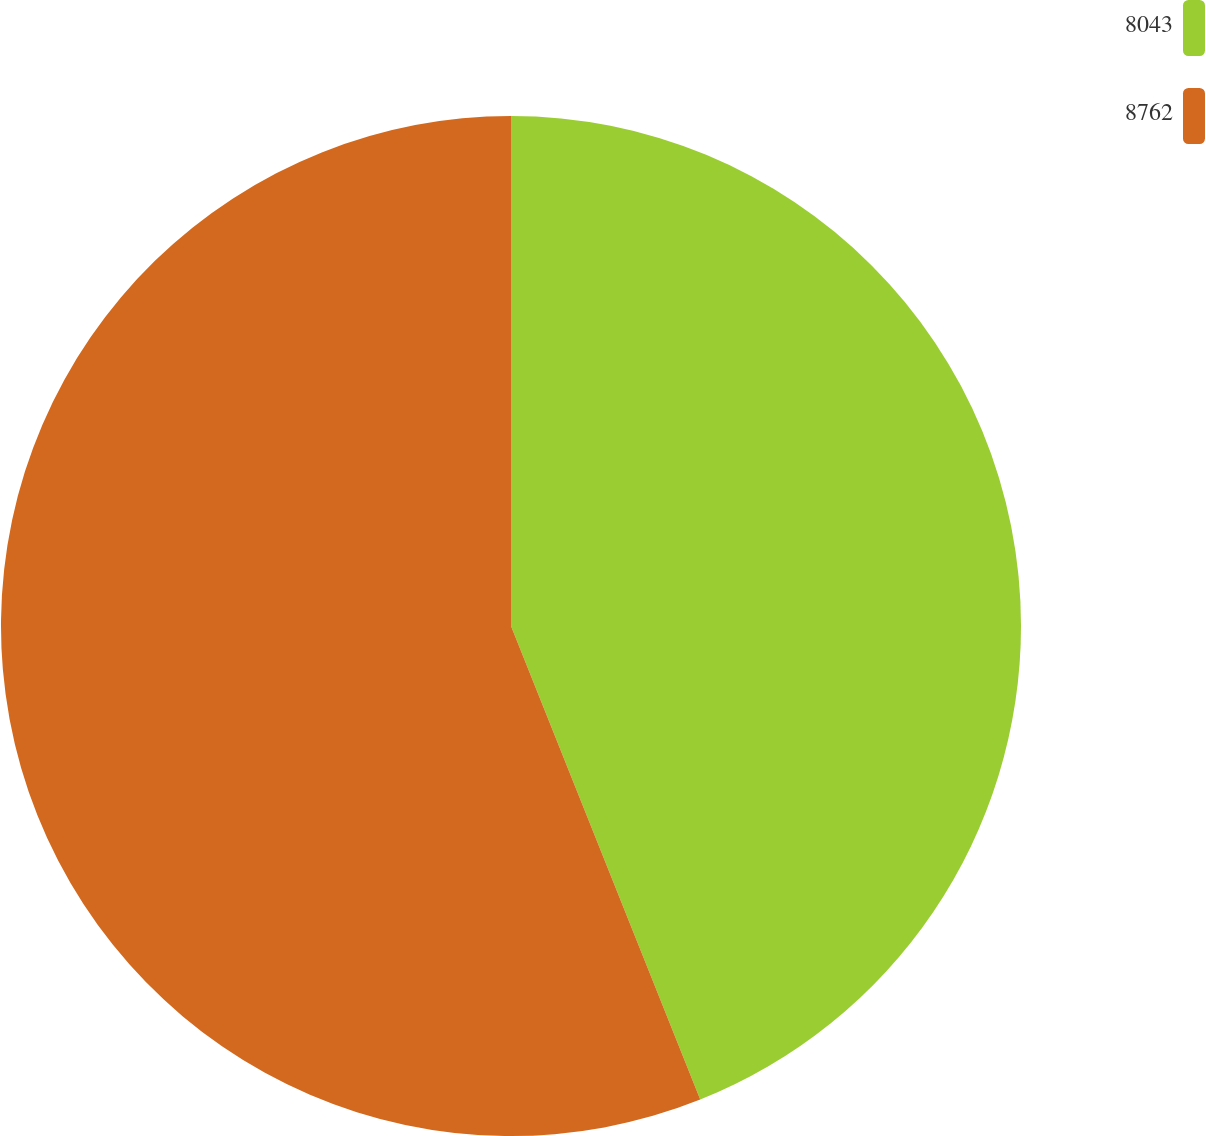Convert chart to OTSL. <chart><loc_0><loc_0><loc_500><loc_500><pie_chart><fcel>8043<fcel>8762<nl><fcel>43.95%<fcel>56.05%<nl></chart> 